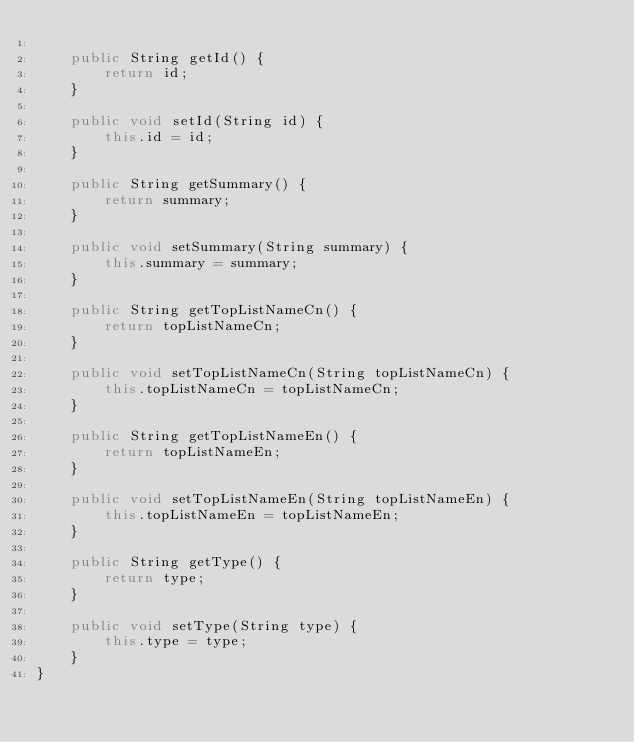<code> <loc_0><loc_0><loc_500><loc_500><_Java_>
    public String getId() {
        return id;
    }

    public void setId(String id) {
        this.id = id;
    }

    public String getSummary() {
        return summary;
    }

    public void setSummary(String summary) {
        this.summary = summary;
    }

    public String getTopListNameCn() {
        return topListNameCn;
    }

    public void setTopListNameCn(String topListNameCn) {
        this.topListNameCn = topListNameCn;
    }

    public String getTopListNameEn() {
        return topListNameEn;
    }

    public void setTopListNameEn(String topListNameEn) {
        this.topListNameEn = topListNameEn;
    }

    public String getType() {
        return type;
    }

    public void setType(String type) {
        this.type = type;
    }
}
</code> 